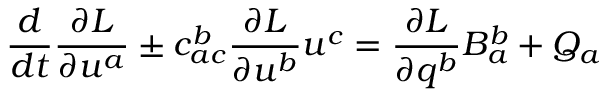Convert formula to latex. <formula><loc_0><loc_0><loc_500><loc_500>\frac { d } { d t } \frac { \partial L } { \partial u ^ { a } } \pm c _ { a c } ^ { b } \frac { \partial L } { \partial u ^ { b } } u ^ { c } = \frac { \partial L } { \partial q ^ { b } } B _ { a } ^ { b } + Q _ { a }</formula> 